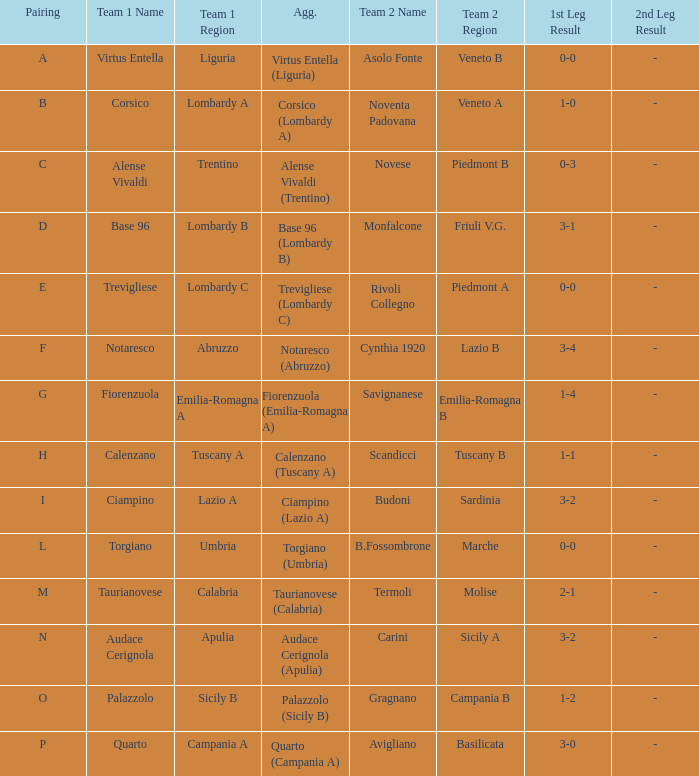Could you parse the entire table? {'header': ['Pairing', 'Team 1 Name', 'Team 1 Region', 'Agg.', 'Team 2 Name', 'Team 2 Region', '1st Leg Result', '2nd Leg Result'], 'rows': [['A', 'Virtus Entella', 'Liguria', 'Virtus Entella (Liguria)', 'Asolo Fonte', 'Veneto B', '0-0', '-'], ['B', 'Corsico', 'Lombardy A', 'Corsico (Lombardy A)', 'Noventa Padovana', 'Veneto A', '1-0', '-'], ['C', 'Alense Vivaldi', 'Trentino', 'Alense Vivaldi (Trentino)', 'Novese', 'Piedmont B', '0-3', '-'], ['D', 'Base 96', 'Lombardy B', 'Base 96 (Lombardy B)', 'Monfalcone', 'Friuli V.G.', '3-1', '-'], ['E', 'Trevigliese', 'Lombardy C', 'Trevigliese (Lombardy C)', 'Rivoli Collegno', 'Piedmont A', '0-0', '-'], ['F', 'Notaresco', 'Abruzzo', 'Notaresco (Abruzzo)', 'Cynthia 1920', 'Lazio B', '3-4', '-'], ['G', 'Fiorenzuola', 'Emilia-Romagna A', 'Fiorenzuola (Emilia-Romagna A)', 'Savignanese', 'Emilia-Romagna B', '1-4', '-'], ['H', 'Calenzano', 'Tuscany A', 'Calenzano (Tuscany A)', 'Scandicci', 'Tuscany B', '1-1', '-'], ['I', 'Ciampino', 'Lazio A', 'Ciampino (Lazio A)', 'Budoni', 'Sardinia', '3-2', '-'], ['L', 'Torgiano', 'Umbria', 'Torgiano (Umbria)', 'B.Fossombrone', 'Marche', '0-0', '-'], ['M', 'Taurianovese', 'Calabria', 'Taurianovese (Calabria)', 'Termoli', 'Molise', '2-1', '-'], ['N', 'Audace Cerignola', 'Apulia', 'Audace Cerignola (Apulia)', 'Carini', 'Sicily A', '3-2', '-'], ['O', 'Palazzolo', 'Sicily B', 'Palazzolo (Sicily B)', 'Gragnano', 'Campania B', '1-2', '-'], ['P', 'Quarto', 'Campania A', 'Quarto (Campania A)', 'Avigliano', 'Basilicata', '3-0', '-']]} What 1st leg has Alense Vivaldi (Trentino) as Agg.? Novese (Piedmont B). 